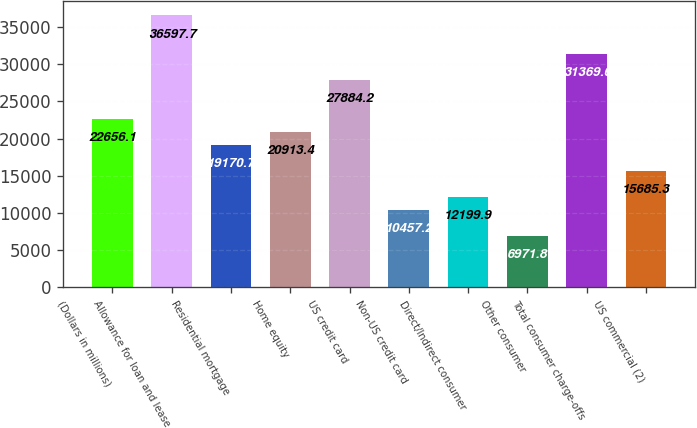<chart> <loc_0><loc_0><loc_500><loc_500><bar_chart><fcel>(Dollars in millions)<fcel>Allowance for loan and lease<fcel>Residential mortgage<fcel>Home equity<fcel>US credit card<fcel>Non-US credit card<fcel>Direct/Indirect consumer<fcel>Other consumer<fcel>Total consumer charge-offs<fcel>US commercial (2)<nl><fcel>22656.1<fcel>36597.7<fcel>19170.7<fcel>20913.4<fcel>27884.2<fcel>10457.2<fcel>12199.9<fcel>6971.8<fcel>31369.6<fcel>15685.3<nl></chart> 